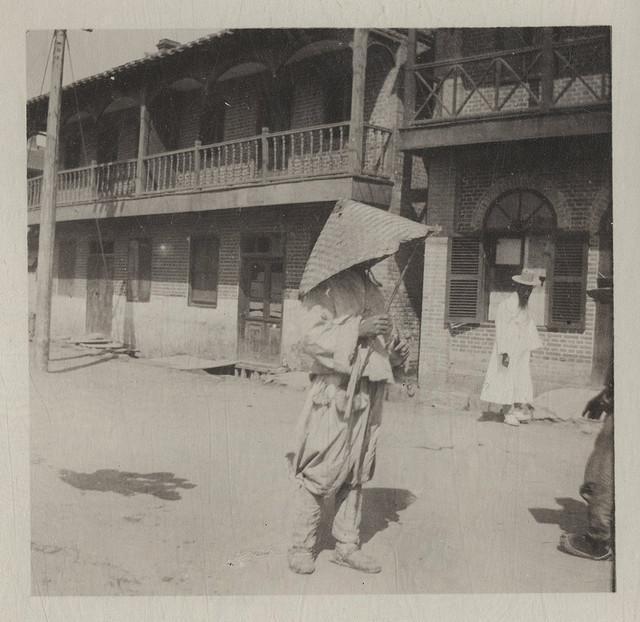How many people can be seen?
Give a very brief answer. 3. How many people are in the picture?
Give a very brief answer. 3. 